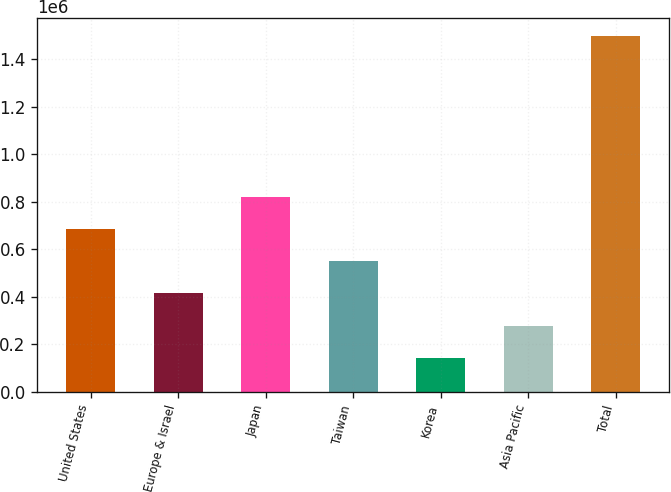Convert chart. <chart><loc_0><loc_0><loc_500><loc_500><bar_chart><fcel>United States<fcel>Europe & Israel<fcel>Japan<fcel>Taiwan<fcel>Korea<fcel>Asia Pacific<fcel>Total<nl><fcel>685015<fcel>414281<fcel>820382<fcel>549648<fcel>143547<fcel>278914<fcel>1.49722e+06<nl></chart> 